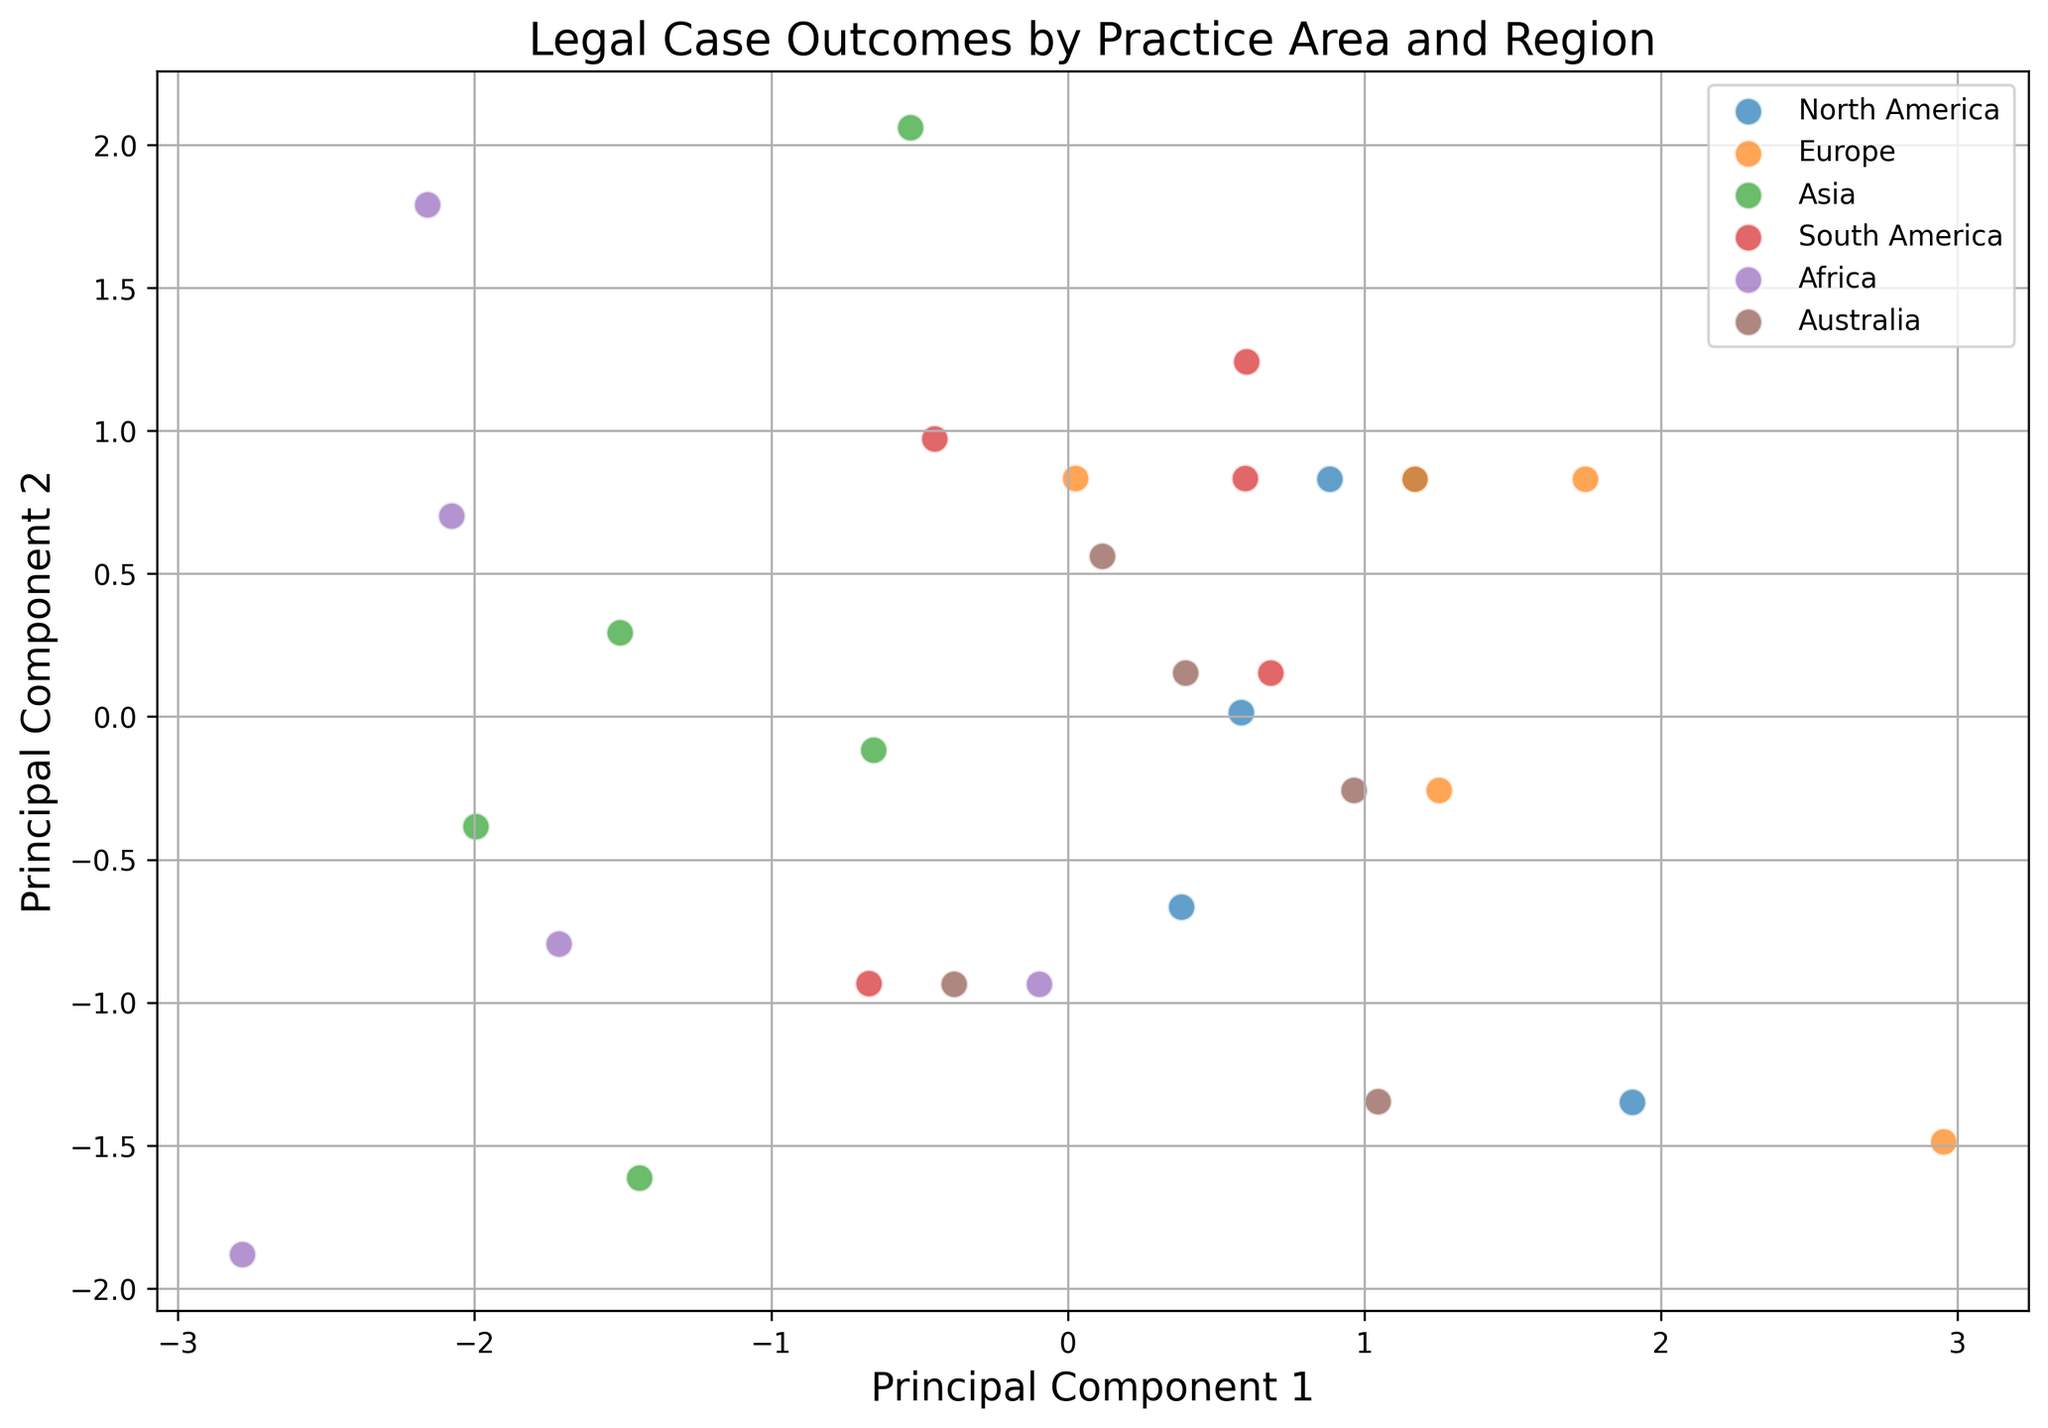Which region has the most distinct cluster in the plot? Observing the plot, we can see which cluster is visually distinct from the others by its separation and grouping. One would look for clusters that stand out due to their position in the PCA space.
Answer: Africa Are there any regions that have overlapping clusters in the plot? By examining the plot for overlaps, we can check if the scatter points for different regions significantly intersect with each other.
Answer: Yes, some clusters overlap Which practice area appears to have the most varied outcomes across all regions? To determine this, we observe the spread of the clusters in the plot. A practice area with varied outcomes is likely to show clusters dispersed over a wide area.
Answer: Intellectual Property Is the cluster for North America closer to the center of the plot or towards the edges? We need to identify the North America cluster and observe its position relative to the center of the plot's PCA coordinates.
Answer: Center How does the separation between Europe and Asia clusters compare visually? By looking at the distance between the Europe and Asia clusters, we can compare how distinct or close they are to each other in the PCA space.
Answer: Europe and Asia clusters are somewhat separated but not completely Which region has the least separation from other regions in its cluster? We focus on clusters that are not well separated from neighboring clusters to see which region's scatter points are closest to others.
Answer: South America Does the Family Law practice area show a trend across regions in the plot? By inspecting the clusters and their position, we look for visual trends or patterns that Family Law might exhibit cross-regionally.
Answer: Yes, there is a trend What can be inferred about the overall performance in Corporate Law from the plot? Observing the clusters labeled for Corporate Law, we can infer trends about its outcome consistency or variability across different regions.
Answer: Mostly consistent but variable in a few regions Between North America and Australia, which region has more spread-out outcomes? By comparing the cluster spread (distance between points) of North America and Australia, we determine which is more dispersed.
Answer: North America Are the clusters for Real Estate Law close to each other across regions? By visually inspecting the positioning of clusters identified as Real Estate Law, we assess their proximity to each other on the plot.
Answer: Yes, they are relatively close 